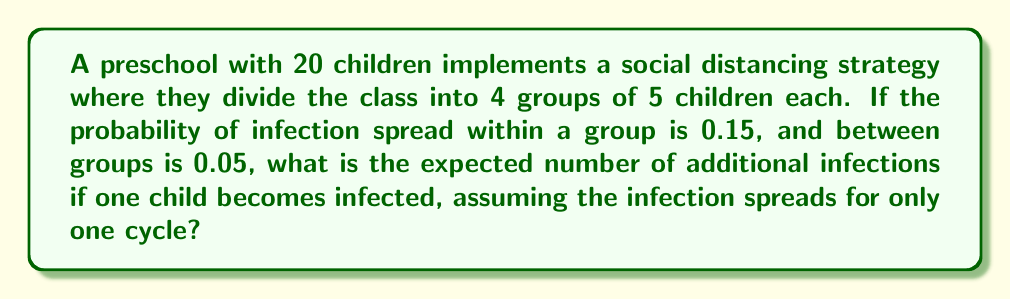Provide a solution to this math problem. Let's break this down step-by-step:

1) First, we need to consider the infections within the infected child's group:
   - There are 4 other children in this group
   - Probability of infection within group = 0.15
   - Expected infections in this group = $4 \times 0.15 = 0.6$

2) Now, let's consider the infections in the other three groups:
   - There are 15 children in the other groups (3 groups of 5)
   - Probability of infection between groups = 0.05
   - Expected infections in other groups = $15 \times 0.05 = 0.75$

3) The total expected number of additional infections is the sum of these two:
   
   $$E(\text{total infections}) = E(\text{within group}) + E(\text{between groups})$$
   $$E(\text{total infections}) = 0.6 + 0.75 = 1.35$$

This result shows that with this social distancing strategy, we expect 1.35 additional infections on average from one initially infected child in a single cycle of spread.
Answer: 1.35 expected additional infections 